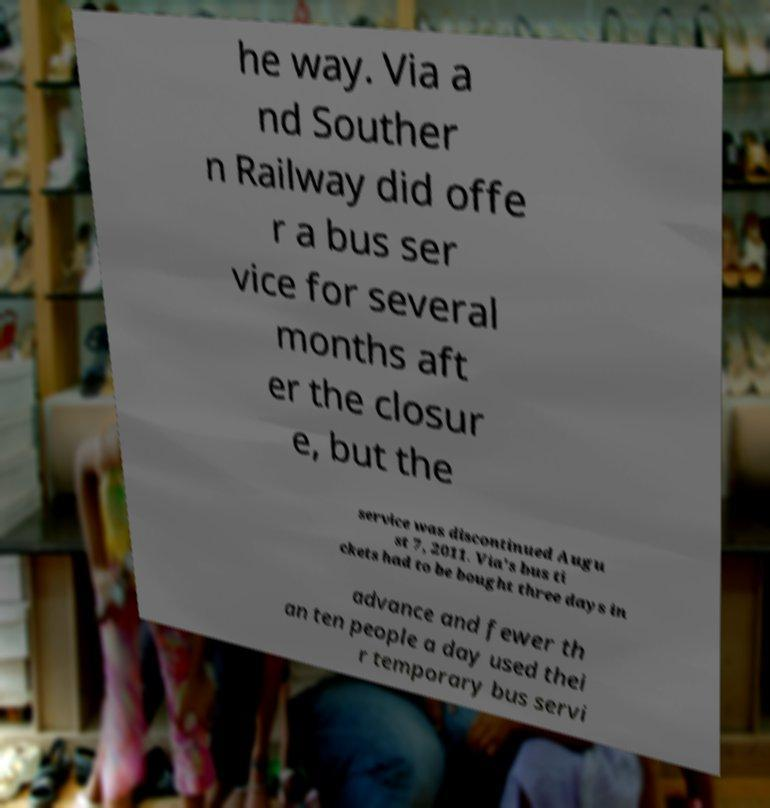For documentation purposes, I need the text within this image transcribed. Could you provide that? he way. Via a nd Souther n Railway did offe r a bus ser vice for several months aft er the closur e, but the service was discontinued Augu st 7, 2011. Via's bus ti ckets had to be bought three days in advance and fewer th an ten people a day used thei r temporary bus servi 